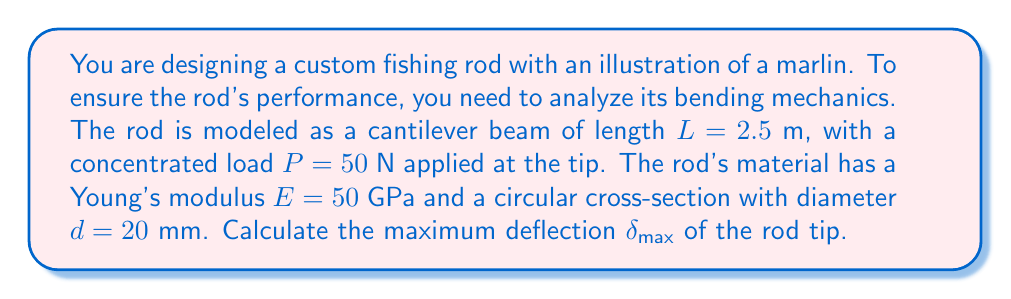Provide a solution to this math problem. To solve this problem, we'll use the deflection formula for a cantilever beam with a concentrated load at the free end:

1. The formula for maximum deflection is:

   $$\delta_{max} = \frac{PL^3}{3EI}$$

   where $I$ is the moment of inertia of the circular cross-section.

2. Calculate the moment of inertia $I$ for a circular cross-section:

   $$I = \frac{\pi d^4}{64} = \frac{\pi (0.02\text{ m})^4}{64} = 7.85 \times 10^{-9} \text{ m}^4$$

3. Convert Young's modulus to N/m²:

   $$E = 50 \text{ GPa} = 50 \times 10^9 \text{ N/m}^2$$

4. Substitute all values into the deflection formula:

   $$\delta_{max} = \frac{50 \text{ N} \times (2.5 \text{ m})^3}{3 \times (50 \times 10^9 \text{ N/m}^2) \times (7.85 \times 10^{-9} \text{ m}^4)}$$

5. Simplify and calculate:

   $$\delta_{max} = \frac{50 \times 15.625}{1177.5} = 0.664 \text{ m}$$

Thus, the maximum deflection of the rod tip is approximately 0.664 meters or 66.4 cm.
Answer: 0.664 m 